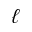Convert formula to latex. <formula><loc_0><loc_0><loc_500><loc_500>\ell</formula> 